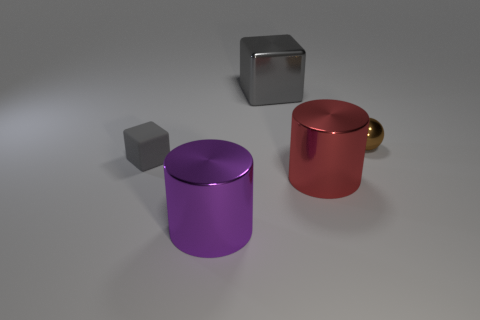There is a tiny thing that is right of the large metallic thing behind the big metal cylinder behind the large purple cylinder; what is its color?
Your answer should be compact. Brown. Are any big metal balls visible?
Ensure brevity in your answer.  No. How many other things are the same size as the matte block?
Provide a succinct answer. 1. Does the metal block have the same color as the block on the left side of the large cube?
Provide a succinct answer. Yes. How many things are gray shiny objects or small gray rubber blocks?
Provide a short and direct response. 2. Is there anything else that has the same color as the metal sphere?
Make the answer very short. No. Does the big red cylinder have the same material as the block that is in front of the shiny block?
Keep it short and to the point. No. What is the shape of the gray thing in front of the small brown thing behind the large red thing?
Make the answer very short. Cube. What shape is the thing that is both to the right of the large gray thing and in front of the tiny cube?
Offer a terse response. Cylinder. What number of things are big blue metallic spheres or things that are on the left side of the ball?
Offer a very short reply. 4. 